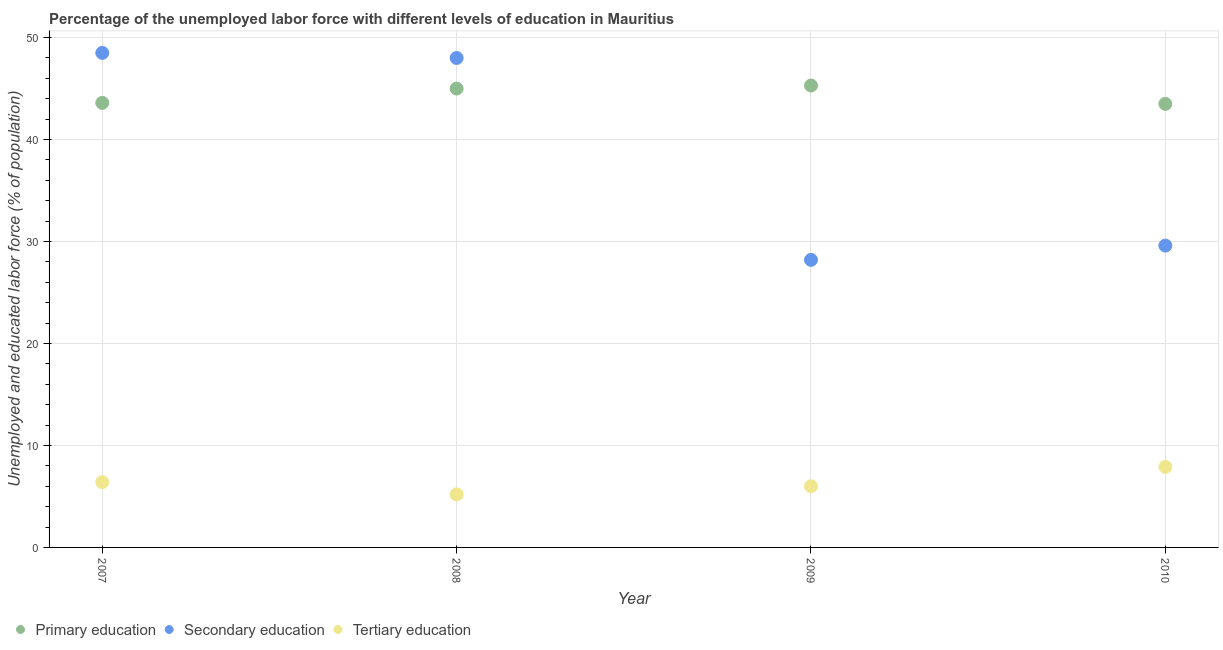How many different coloured dotlines are there?
Offer a terse response. 3. What is the percentage of labor force who received primary education in 2010?
Your response must be concise. 43.5. Across all years, what is the maximum percentage of labor force who received secondary education?
Provide a short and direct response. 48.5. Across all years, what is the minimum percentage of labor force who received primary education?
Offer a very short reply. 43.5. In which year was the percentage of labor force who received primary education minimum?
Your response must be concise. 2010. What is the total percentage of labor force who received tertiary education in the graph?
Ensure brevity in your answer.  25.5. What is the difference between the percentage of labor force who received primary education in 2008 and that in 2009?
Your answer should be very brief. -0.3. What is the difference between the percentage of labor force who received tertiary education in 2008 and the percentage of labor force who received secondary education in 2009?
Make the answer very short. -23. What is the average percentage of labor force who received primary education per year?
Make the answer very short. 44.35. What is the ratio of the percentage of labor force who received tertiary education in 2007 to that in 2008?
Provide a short and direct response. 1.23. Is the difference between the percentage of labor force who received secondary education in 2007 and 2008 greater than the difference between the percentage of labor force who received primary education in 2007 and 2008?
Provide a short and direct response. Yes. What is the difference between the highest and the lowest percentage of labor force who received tertiary education?
Offer a very short reply. 2.7. In how many years, is the percentage of labor force who received primary education greater than the average percentage of labor force who received primary education taken over all years?
Give a very brief answer. 2. Is it the case that in every year, the sum of the percentage of labor force who received primary education and percentage of labor force who received secondary education is greater than the percentage of labor force who received tertiary education?
Give a very brief answer. Yes. Does the percentage of labor force who received primary education monotonically increase over the years?
Provide a succinct answer. No. Is the percentage of labor force who received primary education strictly greater than the percentage of labor force who received secondary education over the years?
Keep it short and to the point. No. How many dotlines are there?
Your answer should be compact. 3. Are the values on the major ticks of Y-axis written in scientific E-notation?
Provide a succinct answer. No. Does the graph contain any zero values?
Your response must be concise. No. Does the graph contain grids?
Offer a very short reply. Yes. How many legend labels are there?
Your response must be concise. 3. What is the title of the graph?
Your answer should be compact. Percentage of the unemployed labor force with different levels of education in Mauritius. Does "Oil sources" appear as one of the legend labels in the graph?
Provide a short and direct response. No. What is the label or title of the Y-axis?
Provide a short and direct response. Unemployed and educated labor force (% of population). What is the Unemployed and educated labor force (% of population) of Primary education in 2007?
Offer a very short reply. 43.6. What is the Unemployed and educated labor force (% of population) of Secondary education in 2007?
Your response must be concise. 48.5. What is the Unemployed and educated labor force (% of population) in Tertiary education in 2007?
Keep it short and to the point. 6.4. What is the Unemployed and educated labor force (% of population) of Secondary education in 2008?
Offer a very short reply. 48. What is the Unemployed and educated labor force (% of population) in Tertiary education in 2008?
Provide a short and direct response. 5.2. What is the Unemployed and educated labor force (% of population) in Primary education in 2009?
Make the answer very short. 45.3. What is the Unemployed and educated labor force (% of population) of Secondary education in 2009?
Ensure brevity in your answer.  28.2. What is the Unemployed and educated labor force (% of population) of Primary education in 2010?
Offer a very short reply. 43.5. What is the Unemployed and educated labor force (% of population) of Secondary education in 2010?
Provide a short and direct response. 29.6. What is the Unemployed and educated labor force (% of population) of Tertiary education in 2010?
Offer a very short reply. 7.9. Across all years, what is the maximum Unemployed and educated labor force (% of population) of Primary education?
Offer a very short reply. 45.3. Across all years, what is the maximum Unemployed and educated labor force (% of population) in Secondary education?
Your answer should be compact. 48.5. Across all years, what is the maximum Unemployed and educated labor force (% of population) in Tertiary education?
Your answer should be very brief. 7.9. Across all years, what is the minimum Unemployed and educated labor force (% of population) in Primary education?
Your answer should be very brief. 43.5. Across all years, what is the minimum Unemployed and educated labor force (% of population) in Secondary education?
Your answer should be compact. 28.2. Across all years, what is the minimum Unemployed and educated labor force (% of population) in Tertiary education?
Give a very brief answer. 5.2. What is the total Unemployed and educated labor force (% of population) of Primary education in the graph?
Offer a terse response. 177.4. What is the total Unemployed and educated labor force (% of population) in Secondary education in the graph?
Give a very brief answer. 154.3. What is the difference between the Unemployed and educated labor force (% of population) in Primary education in 2007 and that in 2008?
Keep it short and to the point. -1.4. What is the difference between the Unemployed and educated labor force (% of population) of Secondary education in 2007 and that in 2008?
Offer a very short reply. 0.5. What is the difference between the Unemployed and educated labor force (% of population) of Tertiary education in 2007 and that in 2008?
Make the answer very short. 1.2. What is the difference between the Unemployed and educated labor force (% of population) in Secondary education in 2007 and that in 2009?
Give a very brief answer. 20.3. What is the difference between the Unemployed and educated labor force (% of population) of Tertiary education in 2007 and that in 2009?
Ensure brevity in your answer.  0.4. What is the difference between the Unemployed and educated labor force (% of population) in Primary education in 2007 and that in 2010?
Keep it short and to the point. 0.1. What is the difference between the Unemployed and educated labor force (% of population) of Tertiary education in 2007 and that in 2010?
Make the answer very short. -1.5. What is the difference between the Unemployed and educated labor force (% of population) of Primary education in 2008 and that in 2009?
Provide a succinct answer. -0.3. What is the difference between the Unemployed and educated labor force (% of population) of Secondary education in 2008 and that in 2009?
Your answer should be very brief. 19.8. What is the difference between the Unemployed and educated labor force (% of population) in Primary education in 2008 and that in 2010?
Provide a succinct answer. 1.5. What is the difference between the Unemployed and educated labor force (% of population) in Secondary education in 2008 and that in 2010?
Provide a succinct answer. 18.4. What is the difference between the Unemployed and educated labor force (% of population) of Primary education in 2009 and that in 2010?
Ensure brevity in your answer.  1.8. What is the difference between the Unemployed and educated labor force (% of population) in Tertiary education in 2009 and that in 2010?
Your response must be concise. -1.9. What is the difference between the Unemployed and educated labor force (% of population) of Primary education in 2007 and the Unemployed and educated labor force (% of population) of Secondary education in 2008?
Keep it short and to the point. -4.4. What is the difference between the Unemployed and educated labor force (% of population) of Primary education in 2007 and the Unemployed and educated labor force (% of population) of Tertiary education in 2008?
Give a very brief answer. 38.4. What is the difference between the Unemployed and educated labor force (% of population) of Secondary education in 2007 and the Unemployed and educated labor force (% of population) of Tertiary education in 2008?
Keep it short and to the point. 43.3. What is the difference between the Unemployed and educated labor force (% of population) in Primary education in 2007 and the Unemployed and educated labor force (% of population) in Secondary education in 2009?
Provide a succinct answer. 15.4. What is the difference between the Unemployed and educated labor force (% of population) of Primary education in 2007 and the Unemployed and educated labor force (% of population) of Tertiary education in 2009?
Your answer should be very brief. 37.6. What is the difference between the Unemployed and educated labor force (% of population) of Secondary education in 2007 and the Unemployed and educated labor force (% of population) of Tertiary education in 2009?
Provide a short and direct response. 42.5. What is the difference between the Unemployed and educated labor force (% of population) in Primary education in 2007 and the Unemployed and educated labor force (% of population) in Tertiary education in 2010?
Provide a short and direct response. 35.7. What is the difference between the Unemployed and educated labor force (% of population) of Secondary education in 2007 and the Unemployed and educated labor force (% of population) of Tertiary education in 2010?
Make the answer very short. 40.6. What is the difference between the Unemployed and educated labor force (% of population) of Primary education in 2008 and the Unemployed and educated labor force (% of population) of Secondary education in 2010?
Offer a terse response. 15.4. What is the difference between the Unemployed and educated labor force (% of population) of Primary education in 2008 and the Unemployed and educated labor force (% of population) of Tertiary education in 2010?
Make the answer very short. 37.1. What is the difference between the Unemployed and educated labor force (% of population) of Secondary education in 2008 and the Unemployed and educated labor force (% of population) of Tertiary education in 2010?
Offer a terse response. 40.1. What is the difference between the Unemployed and educated labor force (% of population) in Primary education in 2009 and the Unemployed and educated labor force (% of population) in Secondary education in 2010?
Offer a terse response. 15.7. What is the difference between the Unemployed and educated labor force (% of population) in Primary education in 2009 and the Unemployed and educated labor force (% of population) in Tertiary education in 2010?
Offer a terse response. 37.4. What is the difference between the Unemployed and educated labor force (% of population) of Secondary education in 2009 and the Unemployed and educated labor force (% of population) of Tertiary education in 2010?
Your answer should be compact. 20.3. What is the average Unemployed and educated labor force (% of population) of Primary education per year?
Keep it short and to the point. 44.35. What is the average Unemployed and educated labor force (% of population) of Secondary education per year?
Provide a short and direct response. 38.58. What is the average Unemployed and educated labor force (% of population) of Tertiary education per year?
Give a very brief answer. 6.38. In the year 2007, what is the difference between the Unemployed and educated labor force (% of population) of Primary education and Unemployed and educated labor force (% of population) of Tertiary education?
Give a very brief answer. 37.2. In the year 2007, what is the difference between the Unemployed and educated labor force (% of population) in Secondary education and Unemployed and educated labor force (% of population) in Tertiary education?
Offer a very short reply. 42.1. In the year 2008, what is the difference between the Unemployed and educated labor force (% of population) of Primary education and Unemployed and educated labor force (% of population) of Tertiary education?
Provide a short and direct response. 39.8. In the year 2008, what is the difference between the Unemployed and educated labor force (% of population) in Secondary education and Unemployed and educated labor force (% of population) in Tertiary education?
Your answer should be very brief. 42.8. In the year 2009, what is the difference between the Unemployed and educated labor force (% of population) of Primary education and Unemployed and educated labor force (% of population) of Tertiary education?
Your answer should be very brief. 39.3. In the year 2010, what is the difference between the Unemployed and educated labor force (% of population) of Primary education and Unemployed and educated labor force (% of population) of Secondary education?
Make the answer very short. 13.9. In the year 2010, what is the difference between the Unemployed and educated labor force (% of population) in Primary education and Unemployed and educated labor force (% of population) in Tertiary education?
Your answer should be compact. 35.6. In the year 2010, what is the difference between the Unemployed and educated labor force (% of population) in Secondary education and Unemployed and educated labor force (% of population) in Tertiary education?
Keep it short and to the point. 21.7. What is the ratio of the Unemployed and educated labor force (% of population) in Primary education in 2007 to that in 2008?
Give a very brief answer. 0.97. What is the ratio of the Unemployed and educated labor force (% of population) of Secondary education in 2007 to that in 2008?
Offer a very short reply. 1.01. What is the ratio of the Unemployed and educated labor force (% of population) in Tertiary education in 2007 to that in 2008?
Make the answer very short. 1.23. What is the ratio of the Unemployed and educated labor force (% of population) of Primary education in 2007 to that in 2009?
Keep it short and to the point. 0.96. What is the ratio of the Unemployed and educated labor force (% of population) in Secondary education in 2007 to that in 2009?
Provide a succinct answer. 1.72. What is the ratio of the Unemployed and educated labor force (% of population) in Tertiary education in 2007 to that in 2009?
Provide a short and direct response. 1.07. What is the ratio of the Unemployed and educated labor force (% of population) of Primary education in 2007 to that in 2010?
Your answer should be very brief. 1. What is the ratio of the Unemployed and educated labor force (% of population) in Secondary education in 2007 to that in 2010?
Make the answer very short. 1.64. What is the ratio of the Unemployed and educated labor force (% of population) of Tertiary education in 2007 to that in 2010?
Provide a succinct answer. 0.81. What is the ratio of the Unemployed and educated labor force (% of population) in Primary education in 2008 to that in 2009?
Make the answer very short. 0.99. What is the ratio of the Unemployed and educated labor force (% of population) of Secondary education in 2008 to that in 2009?
Your answer should be very brief. 1.7. What is the ratio of the Unemployed and educated labor force (% of population) in Tertiary education in 2008 to that in 2009?
Keep it short and to the point. 0.87. What is the ratio of the Unemployed and educated labor force (% of population) of Primary education in 2008 to that in 2010?
Give a very brief answer. 1.03. What is the ratio of the Unemployed and educated labor force (% of population) of Secondary education in 2008 to that in 2010?
Make the answer very short. 1.62. What is the ratio of the Unemployed and educated labor force (% of population) of Tertiary education in 2008 to that in 2010?
Keep it short and to the point. 0.66. What is the ratio of the Unemployed and educated labor force (% of population) in Primary education in 2009 to that in 2010?
Provide a short and direct response. 1.04. What is the ratio of the Unemployed and educated labor force (% of population) in Secondary education in 2009 to that in 2010?
Provide a succinct answer. 0.95. What is the ratio of the Unemployed and educated labor force (% of population) of Tertiary education in 2009 to that in 2010?
Offer a very short reply. 0.76. What is the difference between the highest and the second highest Unemployed and educated labor force (% of population) in Tertiary education?
Provide a succinct answer. 1.5. What is the difference between the highest and the lowest Unemployed and educated labor force (% of population) in Primary education?
Offer a terse response. 1.8. What is the difference between the highest and the lowest Unemployed and educated labor force (% of population) in Secondary education?
Offer a terse response. 20.3. What is the difference between the highest and the lowest Unemployed and educated labor force (% of population) of Tertiary education?
Your answer should be very brief. 2.7. 